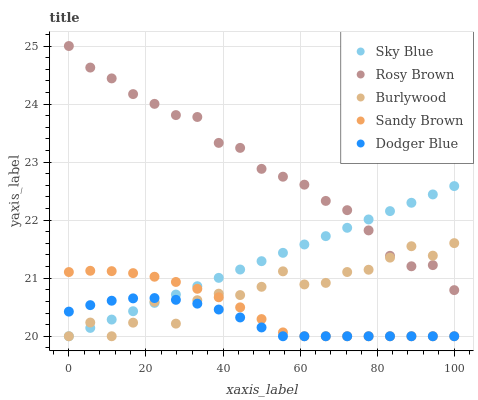Does Dodger Blue have the minimum area under the curve?
Answer yes or no. Yes. Does Rosy Brown have the maximum area under the curve?
Answer yes or no. Yes. Does Sky Blue have the minimum area under the curve?
Answer yes or no. No. Does Sky Blue have the maximum area under the curve?
Answer yes or no. No. Is Sky Blue the smoothest?
Answer yes or no. Yes. Is Burlywood the roughest?
Answer yes or no. Yes. Is Rosy Brown the smoothest?
Answer yes or no. No. Is Rosy Brown the roughest?
Answer yes or no. No. Does Burlywood have the lowest value?
Answer yes or no. Yes. Does Rosy Brown have the lowest value?
Answer yes or no. No. Does Rosy Brown have the highest value?
Answer yes or no. Yes. Does Sky Blue have the highest value?
Answer yes or no. No. Is Dodger Blue less than Rosy Brown?
Answer yes or no. Yes. Is Rosy Brown greater than Sandy Brown?
Answer yes or no. Yes. Does Sky Blue intersect Dodger Blue?
Answer yes or no. Yes. Is Sky Blue less than Dodger Blue?
Answer yes or no. No. Is Sky Blue greater than Dodger Blue?
Answer yes or no. No. Does Dodger Blue intersect Rosy Brown?
Answer yes or no. No. 